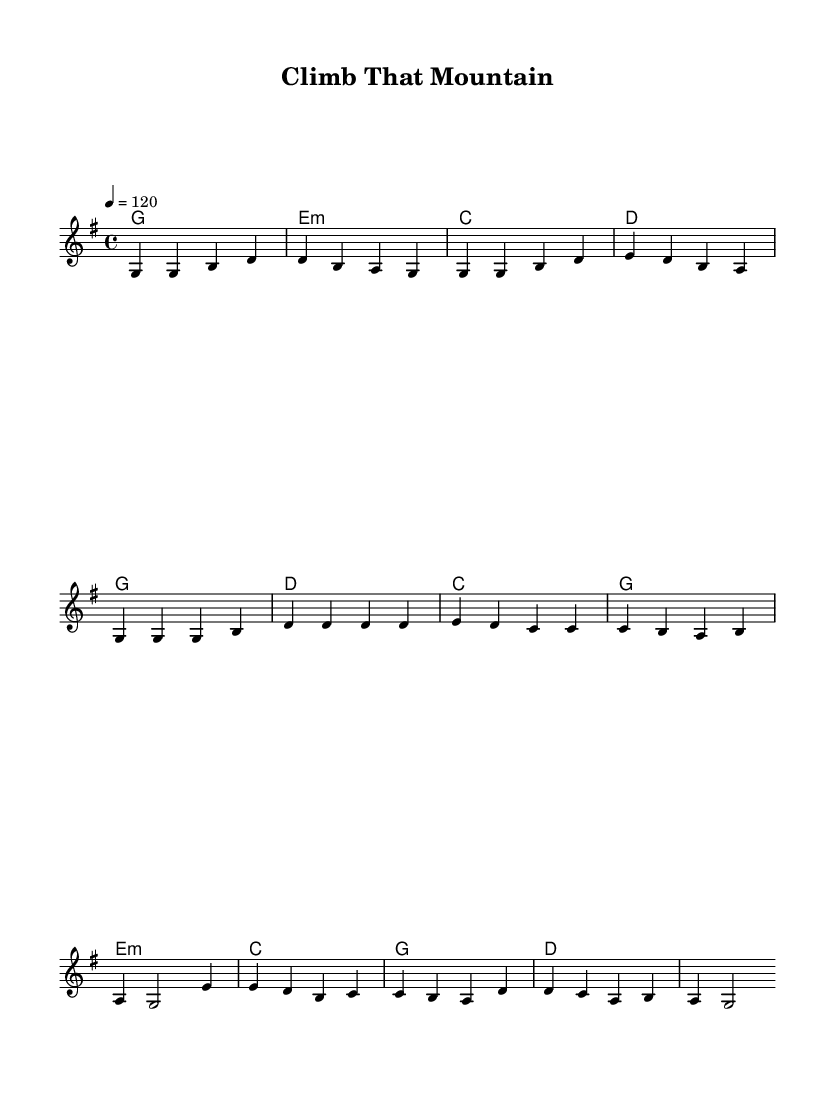What is the key signature of this music? The key signature is G major, which has one sharp (F#). This can be identified in the global section where the key is stated as \key g \major.
Answer: G major What is the time signature of this music? The time signature is 4/4, indicated in the global section with the notation \time 4/4. This means there are four beats per measure and a quarter note gets one beat.
Answer: 4/4 What is the tempo marking of this piece? The tempo marking is 120 beats per minute, as stated in the global section with the notation \tempo 4 = 120. This indicates the speed at which the piece should be played.
Answer: 120 How many measures are in the verse? There are four measures in the verse; this can be seen in the melody section where there are four groups of notes before moving to the chorus.
Answer: 4 What is the chord progression for the chorus? The chord progression for the chorus is G, D, C, G. This is derived from the harmonies section where the chords are listed above the melody for the chorus part.
Answer: G, D, C, G What is the primary theme of this song based on its title and lyrics? The primary theme of the song is overcoming challenges, as indicated by the title "Climb That Mountain." This evokes imagery of striving and perseverance, common in country rock anthems.
Answer: Overcoming challenges What type of musical style does this piece represent? This piece represents the country rock style, characterized by its blend of traditional country music elements with rock music features, as seen in the use of anthem-like melodies and uplifting themes.
Answer: Country rock 